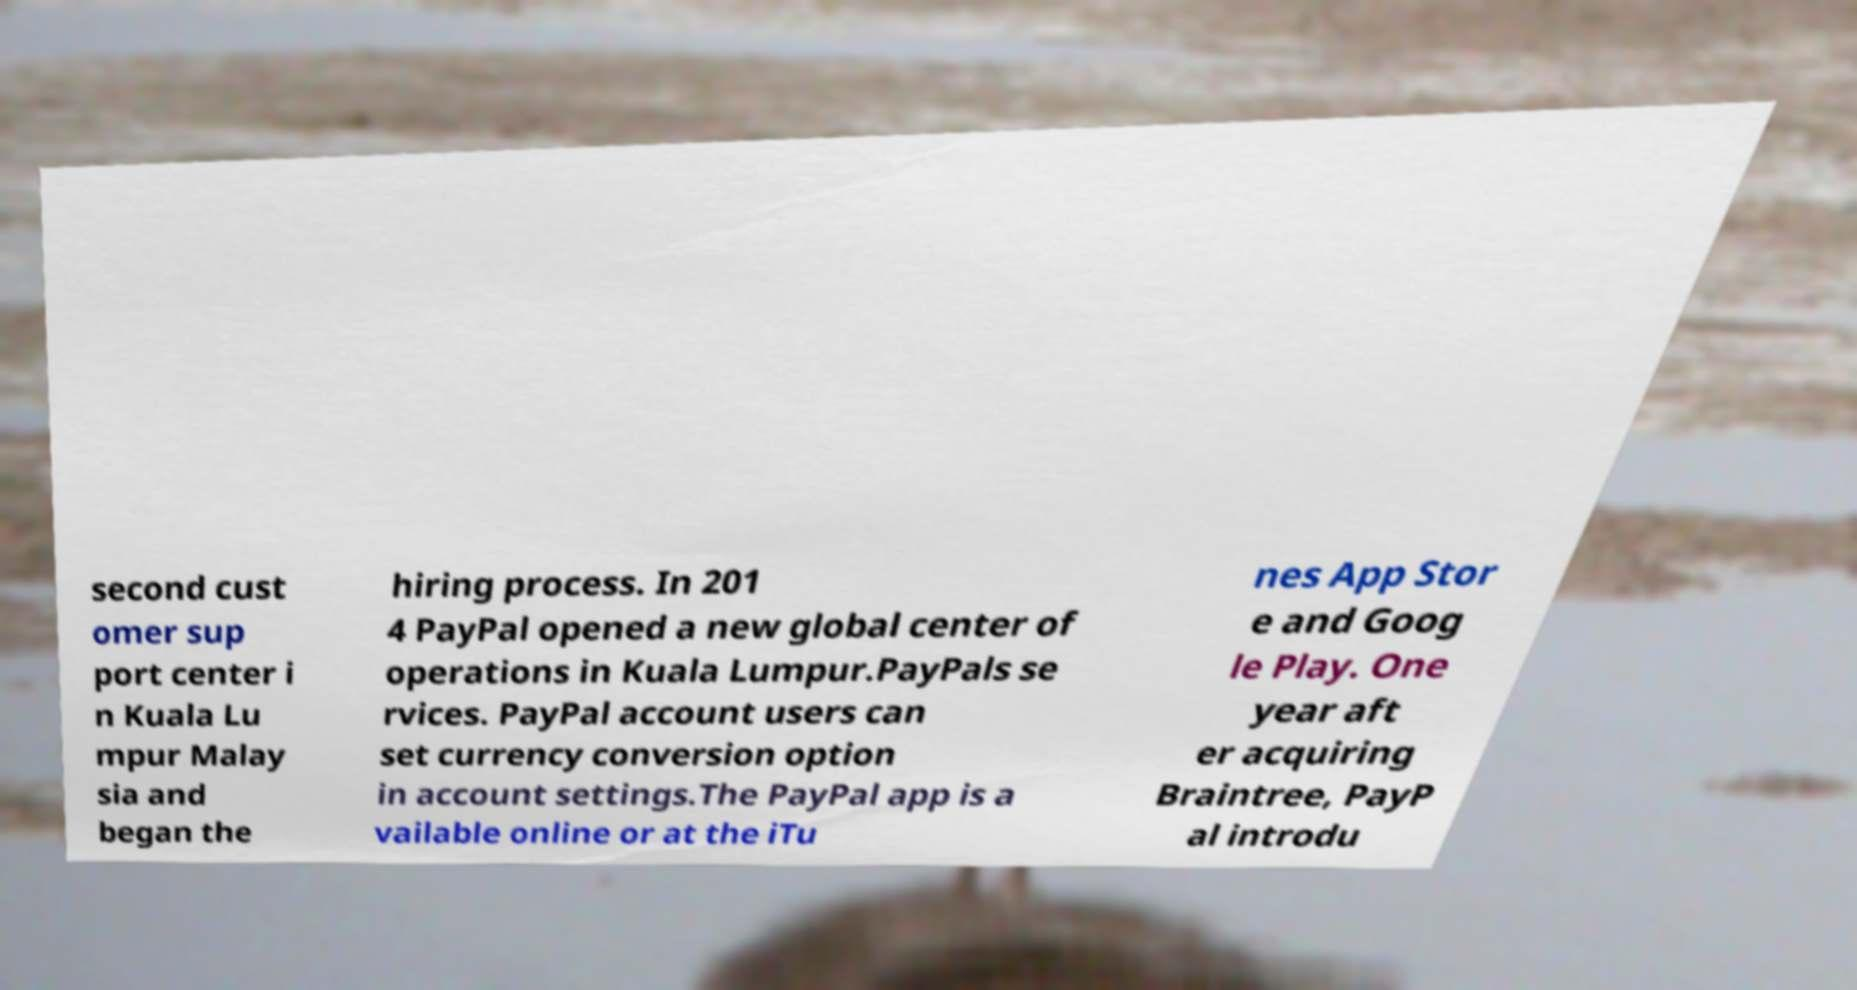Can you read and provide the text displayed in the image?This photo seems to have some interesting text. Can you extract and type it out for me? second cust omer sup port center i n Kuala Lu mpur Malay sia and began the hiring process. In 201 4 PayPal opened a new global center of operations in Kuala Lumpur.PayPals se rvices. PayPal account users can set currency conversion option in account settings.The PayPal app is a vailable online or at the iTu nes App Stor e and Goog le Play. One year aft er acquiring Braintree, PayP al introdu 